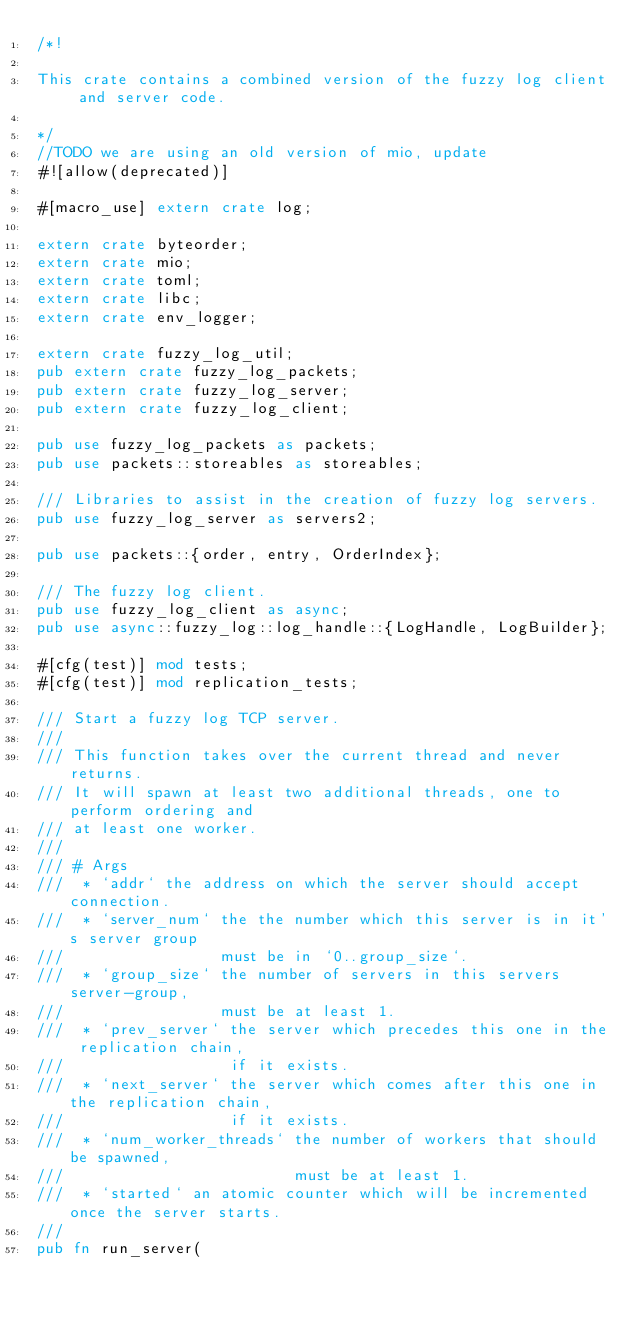<code> <loc_0><loc_0><loc_500><loc_500><_Rust_>/*!

This crate contains a combined version of the fuzzy log client and server code.

*/
//TODO we are using an old version of mio, update
#![allow(deprecated)]

#[macro_use] extern crate log;

extern crate byteorder;
extern crate mio;
extern crate toml;
extern crate libc;
extern crate env_logger;

extern crate fuzzy_log_util;
pub extern crate fuzzy_log_packets;
pub extern crate fuzzy_log_server;
pub extern crate fuzzy_log_client;

pub use fuzzy_log_packets as packets;
pub use packets::storeables as storeables;

/// Libraries to assist in the creation of fuzzy log servers.
pub use fuzzy_log_server as servers2;

pub use packets::{order, entry, OrderIndex};

/// The fuzzy log client.
pub use fuzzy_log_client as async;
pub use async::fuzzy_log::log_handle::{LogHandle, LogBuilder};

#[cfg(test)] mod tests;
#[cfg(test)] mod replication_tests;

/// Start a fuzzy log TCP server.
///
/// This function takes over the current thread and never returns.
/// It will spawn at least two additional threads, one to perform ordering and
/// at least one worker.
///
/// # Args
///  * `addr` the address on which the server should accept connection.
///  * `server_num` the the number which this server is in it's server group
///                 must be in `0..group_size`.
///  * `group_size` the number of servers in this servers server-group,
///                 must be at least 1.
///  * `prev_server` the server which precedes this one in the replication chain,
///                  if it exists.
///  * `next_server` the server which comes after this one in the replication chain,
///                  if it exists.
///  * `num_worker_threads` the number of workers that should be spawned,
///                         must be at least 1.
///  * `started` an atomic counter which will be incremented once the server starts.
///
pub fn run_server(</code> 